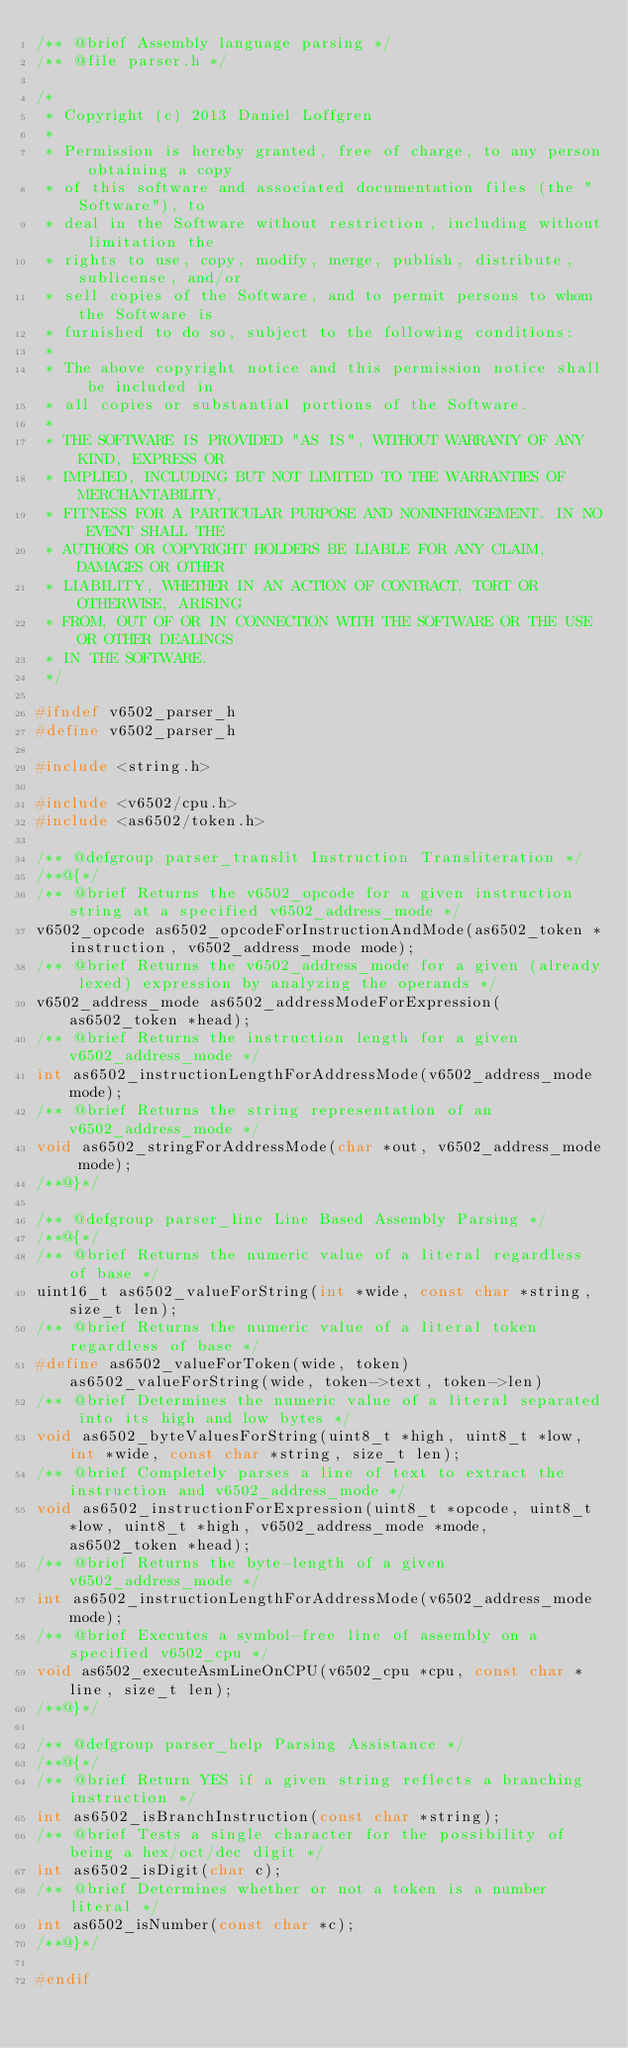Convert code to text. <code><loc_0><loc_0><loc_500><loc_500><_C_>/** @brief Assembly language parsing */
/** @file parser.h */

/*
 * Copyright (c) 2013 Daniel Loffgren
 *
 * Permission is hereby granted, free of charge, to any person obtaining a copy
 * of this software and associated documentation files (the "Software"), to
 * deal in the Software without restriction, including without limitation the
 * rights to use, copy, modify, merge, publish, distribute, sublicense, and/or
 * sell copies of the Software, and to permit persons to whom the Software is
 * furnished to do so, subject to the following conditions:
 *
 * The above copyright notice and this permission notice shall be included in
 * all copies or substantial portions of the Software.
 *
 * THE SOFTWARE IS PROVIDED "AS IS", WITHOUT WARRANTY OF ANY KIND, EXPRESS OR
 * IMPLIED, INCLUDING BUT NOT LIMITED TO THE WARRANTIES OF MERCHANTABILITY,
 * FITNESS FOR A PARTICULAR PURPOSE AND NONINFRINGEMENT. IN NO EVENT SHALL THE
 * AUTHORS OR COPYRIGHT HOLDERS BE LIABLE FOR ANY CLAIM, DAMAGES OR OTHER
 * LIABILITY, WHETHER IN AN ACTION OF CONTRACT, TORT OR OTHERWISE, ARISING
 * FROM, OUT OF OR IN CONNECTION WITH THE SOFTWARE OR THE USE OR OTHER DEALINGS
 * IN THE SOFTWARE.
 */

#ifndef v6502_parser_h
#define v6502_parser_h

#include <string.h>

#include <v6502/cpu.h>
#include <as6502/token.h>

/** @defgroup parser_translit Instruction Transliteration */
/**@{*/
/** @brief Returns the v6502_opcode for a given instruction string at a specified v6502_address_mode */
v6502_opcode as6502_opcodeForInstructionAndMode(as6502_token *instruction, v6502_address_mode mode);
/** @brief Returns the v6502_address_mode for a given (already lexed) expression by analyzing the operands */
v6502_address_mode as6502_addressModeForExpression(as6502_token *head);
/** @brief Returns the instruction length for a given v6502_address_mode */
int as6502_instructionLengthForAddressMode(v6502_address_mode mode);
/** @brief Returns the string representation of an v6502_address_mode */
void as6502_stringForAddressMode(char *out, v6502_address_mode mode);
/**@}*/

/** @defgroup parser_line Line Based Assembly Parsing */
/**@{*/
/** @brief Returns the numeric value of a literal regardless of base */
uint16_t as6502_valueForString(int *wide, const char *string, size_t len);
/** @brief Returns the numeric value of a literal token regardless of base */
#define as6502_valueForToken(wide, token)	as6502_valueForString(wide, token->text, token->len)
/** @brief Determines the numeric value of a literal separated into its high and low bytes */
void as6502_byteValuesForString(uint8_t *high, uint8_t *low, int *wide, const char *string, size_t len);
/** @brief Completely parses a line of text to extract the instruction and v6502_address_mode */
void as6502_instructionForExpression(uint8_t *opcode, uint8_t *low, uint8_t *high, v6502_address_mode *mode, as6502_token *head);
/** @brief Returns the byte-length of a given v6502_address_mode */
int as6502_instructionLengthForAddressMode(v6502_address_mode mode);
/** @brief Executes a symbol-free line of assembly on a specified v6502_cpu */
void as6502_executeAsmLineOnCPU(v6502_cpu *cpu, const char *line, size_t len);
/**@}*/

/** @defgroup parser_help Parsing Assistance */
/**@{*/
/** @brief Return YES if a given string reflects a branching instruction */
int as6502_isBranchInstruction(const char *string);
/** @brief Tests a single character for the possibility of being a hex/oct/dec digit */
int as6502_isDigit(char c);
/** @brief Determines whether or not a token is a number literal */
int as6502_isNumber(const char *c);
/**@}*/

#endif
</code> 